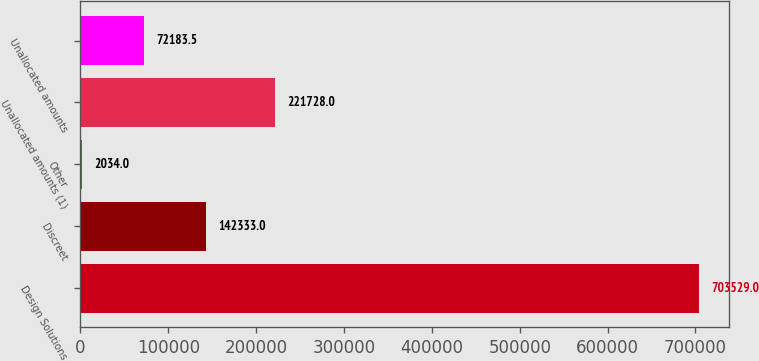Convert chart to OTSL. <chart><loc_0><loc_0><loc_500><loc_500><bar_chart><fcel>Design Solutions<fcel>Discreet<fcel>Other<fcel>Unallocated amounts (1)<fcel>Unallocated amounts<nl><fcel>703529<fcel>142333<fcel>2034<fcel>221728<fcel>72183.5<nl></chart> 